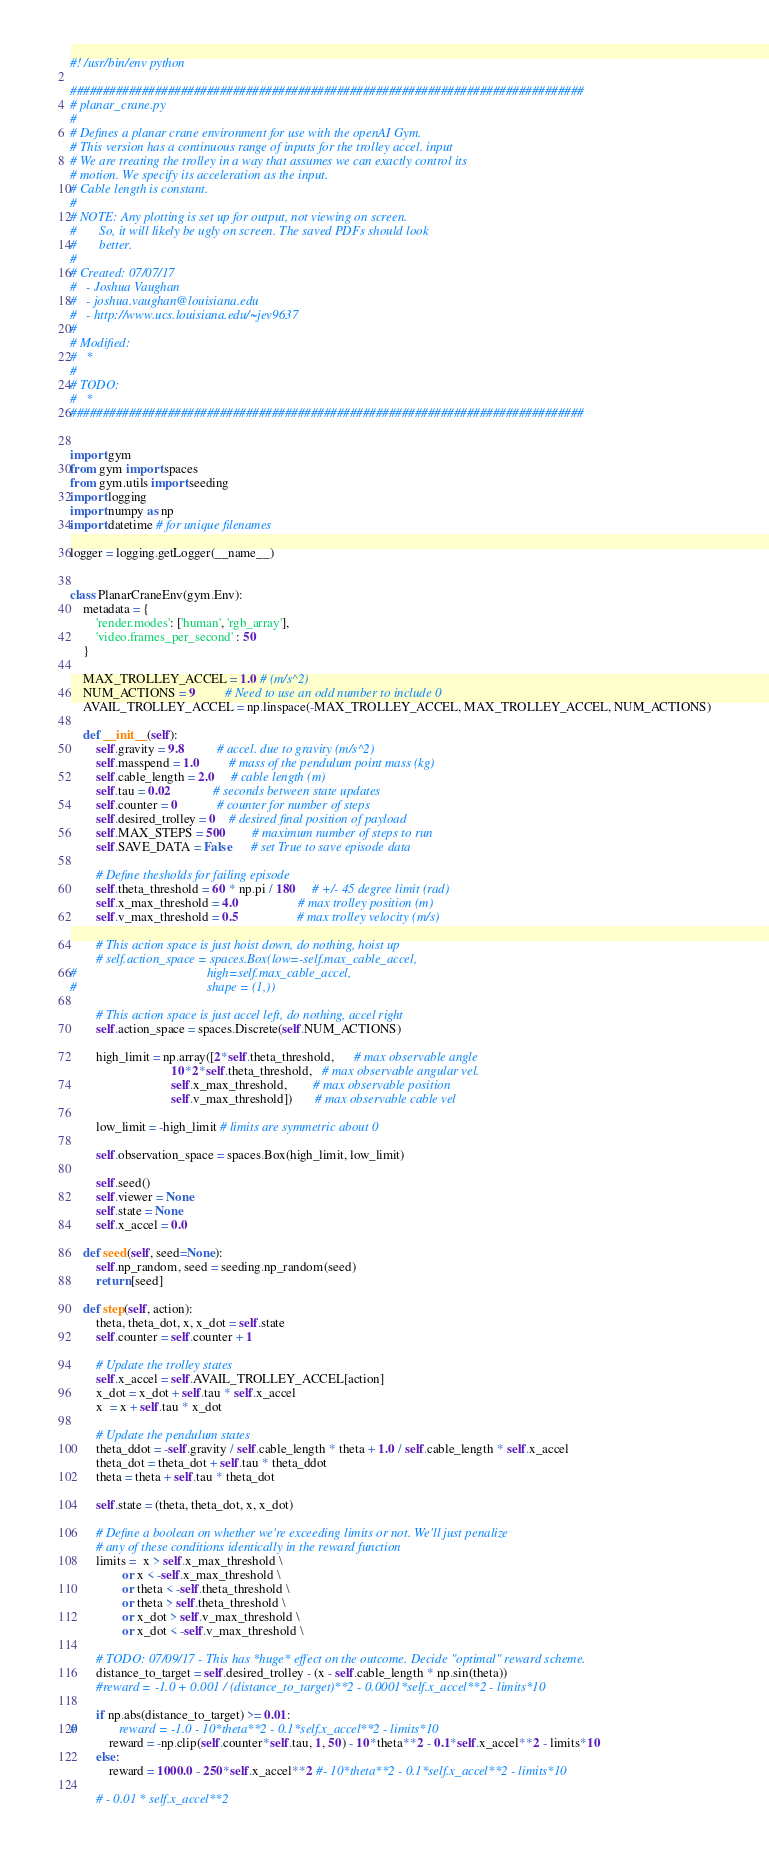Convert code to text. <code><loc_0><loc_0><loc_500><loc_500><_Python_>#! /usr/bin/env python

###############################################################################
# planar_crane.py
#
# Defines a planar crane environment for use with the openAI Gym.
# This version has a continuous range of inputs for the trolley accel. input
# We are treating the trolley in a way that assumes we can exactly control its 
# motion. We specify its acceleration as the input.
# Cable length is constant.
#
# NOTE: Any plotting is set up for output, not viewing on screen.
#       So, it will likely be ugly on screen. The saved PDFs should look
#       better.
#
# Created: 07/07/17
#   - Joshua Vaughan
#   - joshua.vaughan@louisiana.edu
#   - http://www.ucs.louisiana.edu/~jev9637
#
# Modified:
#   * 
#
# TODO:
#   * 
###############################################################################


import gym
from gym import spaces
from gym.utils import seeding
import logging
import numpy as np
import datetime # for unique filenames

logger = logging.getLogger(__name__)


class PlanarCraneEnv(gym.Env):
    metadata = {
        'render.modes': ['human', 'rgb_array'],
        'video.frames_per_second' : 50
    }
    
    MAX_TROLLEY_ACCEL = 1.0 # (m/s^2)
    NUM_ACTIONS = 9         # Need to use an odd number to include 0
    AVAIL_TROLLEY_ACCEL = np.linspace(-MAX_TROLLEY_ACCEL, MAX_TROLLEY_ACCEL, NUM_ACTIONS)
    
    def __init__(self):
        self.gravity = 9.8          # accel. due to gravity (m/s^2)
        self.masspend = 1.0         # mass of the pendulum point mass (kg)
        self.cable_length = 2.0     # cable length (m)
        self.tau = 0.02             # seconds between state updates
        self.counter = 0            # counter for number of steps
        self.desired_trolley = 0    # desired final position of payload
        self.MAX_STEPS = 500        # maximum number of steps to run
        self.SAVE_DATA = False      # set True to save episode data
        
        # Define thesholds for failing episode
        self.theta_threshold = 60 * np.pi / 180     # +/- 45 degree limit (rad)
        self.x_max_threshold = 4.0                  # max trolley position (m)
        self.v_max_threshold = 0.5                  # max trolley velocity (m/s)

        # This action space is just hoist down, do nothing, hoist up
        # self.action_space = spaces.Box(low=-self.max_cable_accel,
#                                        high=self.max_cable_accel, 
#                                        shape = (1,))

        # This action space is just accel left, do nothing, accel right
        self.action_space = spaces.Discrete(self.NUM_ACTIONS)
        
        high_limit = np.array([2*self.theta_threshold,      # max observable angle 
                               10*2*self.theta_threshold,   # max observable angular vel.
                               self.x_max_threshold,        # max observable position
                               self.v_max_threshold])       # max observable cable vel

        low_limit = -high_limit # limits are symmetric about 0
        
        self.observation_space = spaces.Box(high_limit, low_limit)

        self.seed()
        self.viewer = None
        self.state = None
        self.x_accel = 0.0

    def seed(self, seed=None):
        self.np_random, seed = seeding.np_random(seed)
        return [seed]

    def step(self, action):
        theta, theta_dot, x, x_dot = self.state
        self.counter = self.counter + 1
        
        # Update the trolley states
        self.x_accel = self.AVAIL_TROLLEY_ACCEL[action]
        x_dot = x_dot + self.tau * self.x_accel
        x  = x + self.tau * x_dot

        # Update the pendulum states
        theta_ddot = -self.gravity / self.cable_length * theta + 1.0 / self.cable_length * self.x_accel
        theta_dot = theta_dot + self.tau * theta_ddot
        theta = theta + self.tau * theta_dot

        self.state = (theta, theta_dot, x, x_dot)
        
        # Define a boolean on whether we're exceeding limits or not. We'll just penalize
        # any of these conditions identically in the reward function
        limits =  x > self.x_max_threshold \
                or x < -self.x_max_threshold \
                or theta < -self.theta_threshold \
                or theta > self.theta_threshold \
                or x_dot > self.v_max_threshold \
                or x_dot < -self.v_max_threshold \

        # TODO: 07/09/17 - This has *huge* effect on the outcome. Decide "optimal" reward scheme.
        distance_to_target = self.desired_trolley - (x - self.cable_length * np.sin(theta))
        #reward = -1.0 + 0.001 / (distance_to_target)**2 - 0.0001*self.x_accel**2 - limits*10
        
        if np.abs(distance_to_target) >= 0.01:
#             reward = -1.0 - 10*theta**2 - 0.1*self.x_accel**2 - limits*10
            reward = -np.clip(self.counter*self.tau, 1, 50) - 10*theta**2 - 0.1*self.x_accel**2 - limits*10
        else:  
            reward = 1000.0 - 250*self.x_accel**2 #- 10*theta**2 - 0.1*self.x_accel**2 - limits*10

        # - 0.01 * self.x_accel**2</code> 